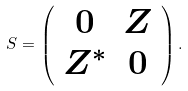Convert formula to latex. <formula><loc_0><loc_0><loc_500><loc_500>S = \left ( \begin{array} { c c } 0 & Z \\ Z ^ { * } & 0 \end{array} \right ) .</formula> 